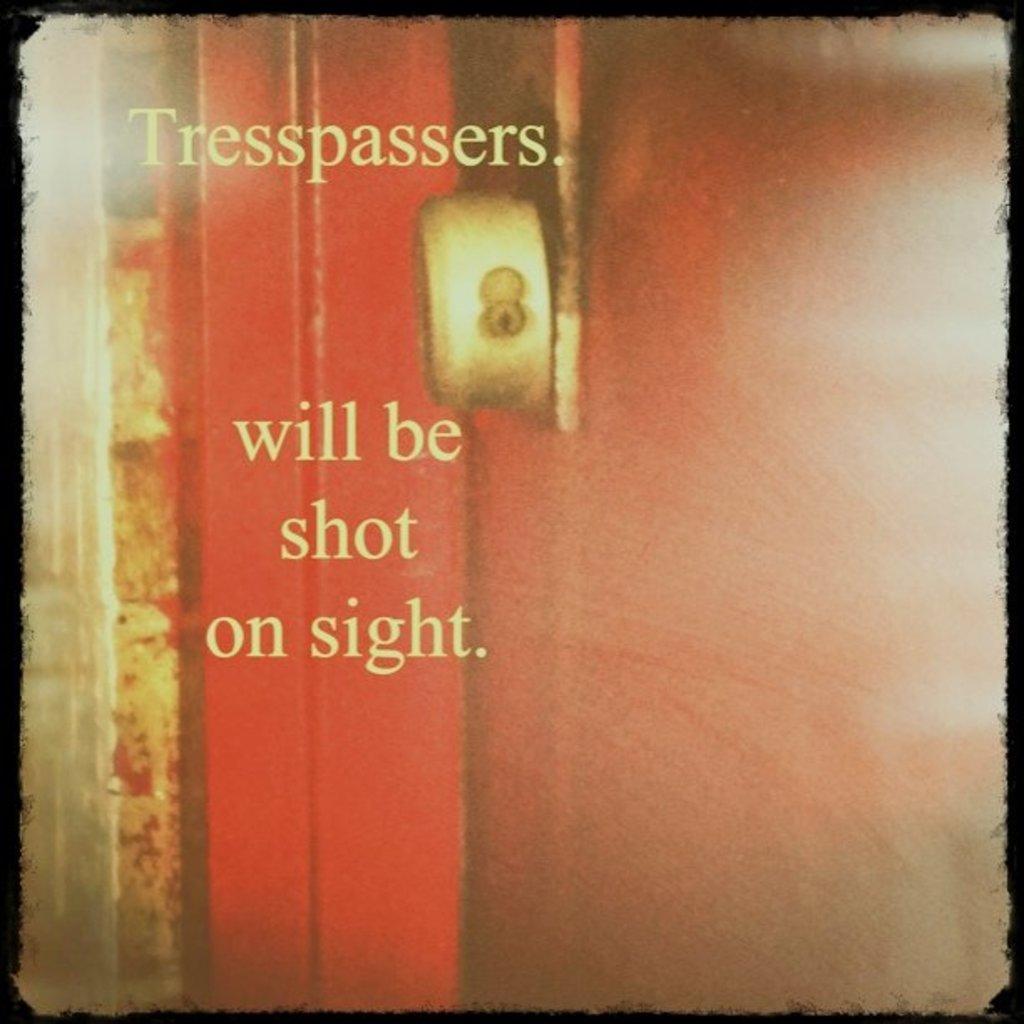What will happen to trespassers?
Make the answer very short. Will be shot on sight. Who will be shot on sight?
Your answer should be very brief. Tresspassers. 